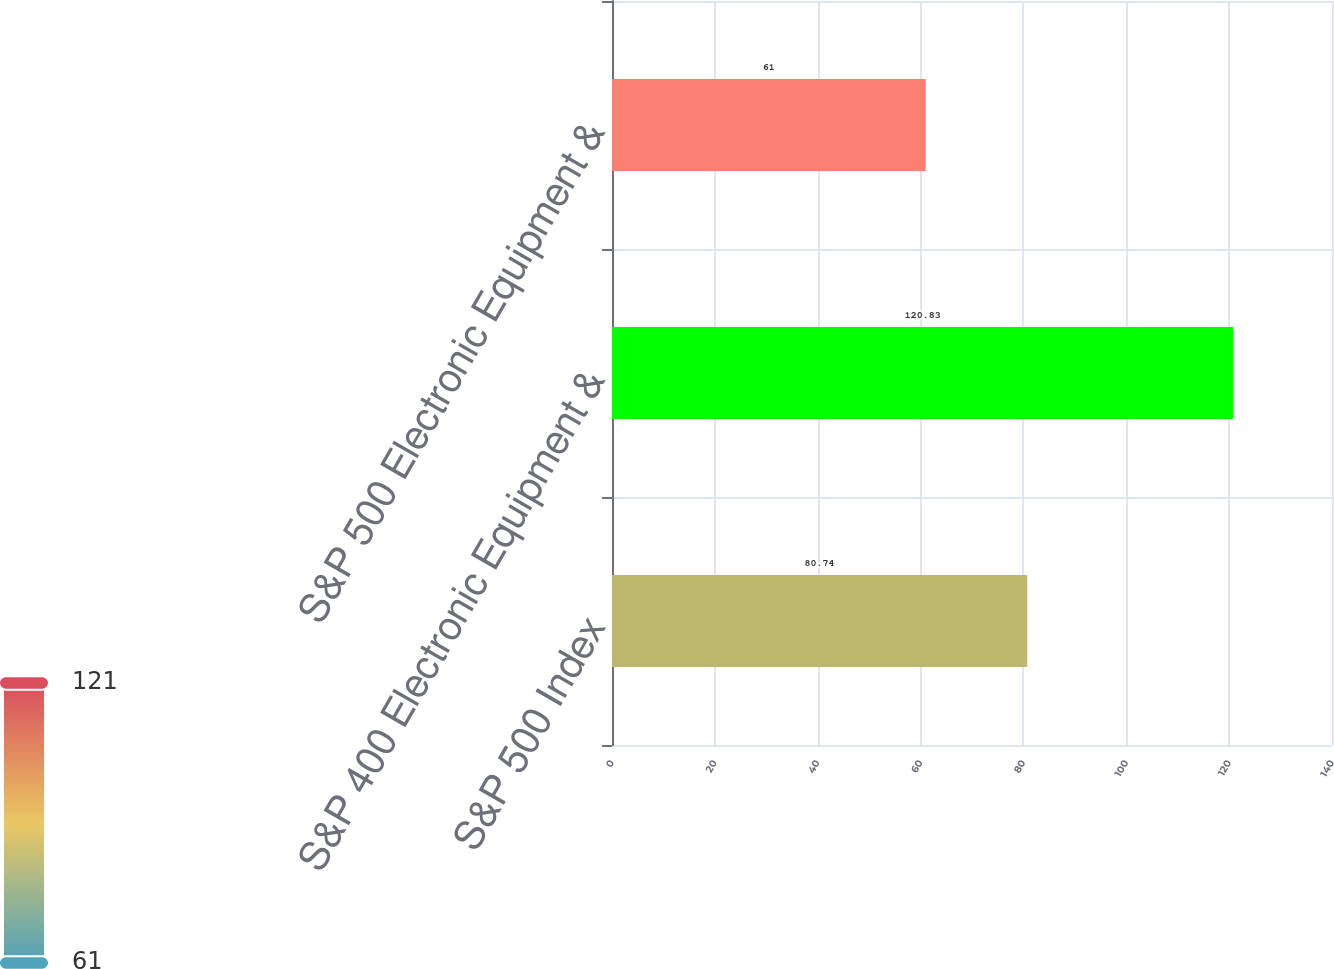Convert chart. <chart><loc_0><loc_0><loc_500><loc_500><bar_chart><fcel>S&P 500 Index<fcel>S&P 400 Electronic Equipment &<fcel>S&P 500 Electronic Equipment &<nl><fcel>80.74<fcel>120.83<fcel>61<nl></chart> 